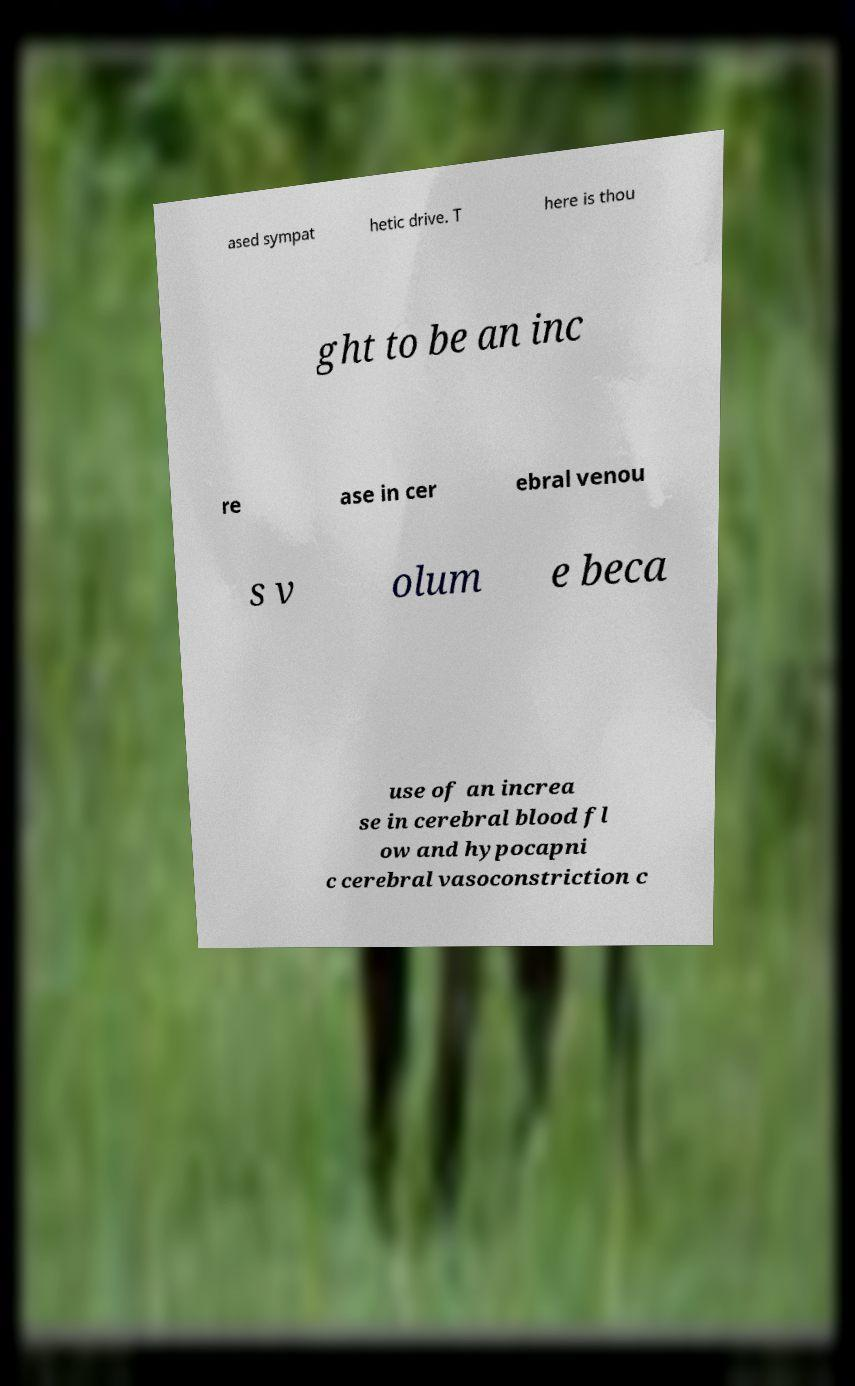Please identify and transcribe the text found in this image. ased sympat hetic drive. T here is thou ght to be an inc re ase in cer ebral venou s v olum e beca use of an increa se in cerebral blood fl ow and hypocapni c cerebral vasoconstriction c 